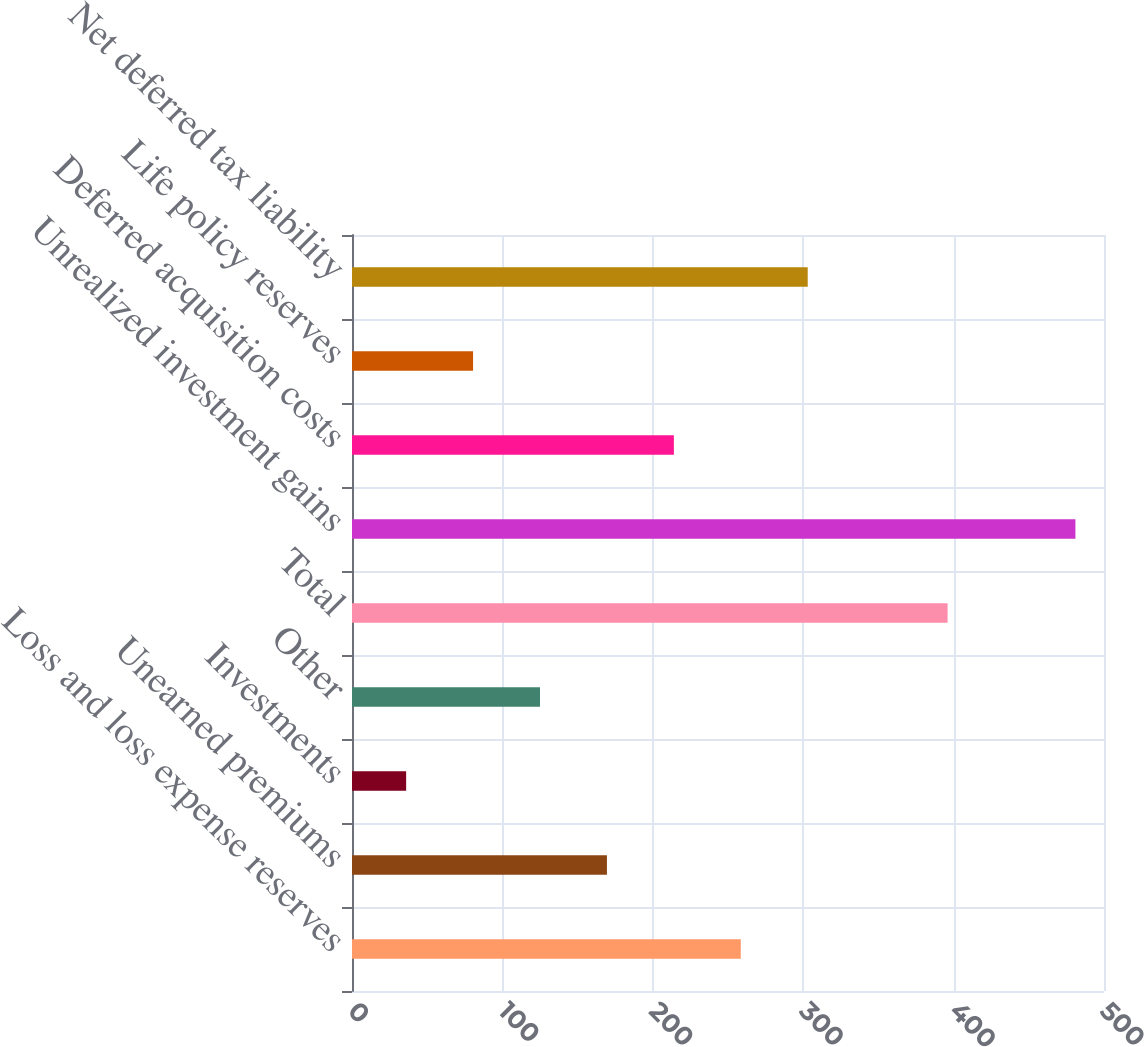Convert chart. <chart><loc_0><loc_0><loc_500><loc_500><bar_chart><fcel>Loss and loss expense reserves<fcel>Unearned premiums<fcel>Investments<fcel>Other<fcel>Total<fcel>Unrealized investment gains<fcel>Deferred acquisition costs<fcel>Life policy reserves<fcel>Net deferred tax liability<nl><fcel>258.5<fcel>169.5<fcel>36<fcel>125<fcel>396<fcel>481<fcel>214<fcel>80.5<fcel>303<nl></chart> 